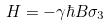Convert formula to latex. <formula><loc_0><loc_0><loc_500><loc_500>H = - \gamma \hbar { B } \sigma _ { 3 }</formula> 